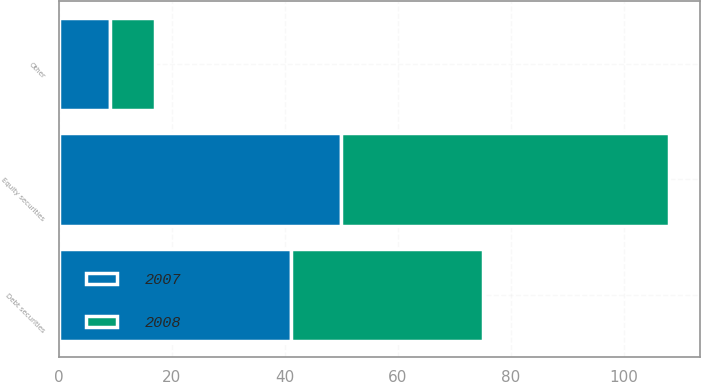Convert chart to OTSL. <chart><loc_0><loc_0><loc_500><loc_500><stacked_bar_chart><ecel><fcel>Equity securities<fcel>Debt securities<fcel>Other<nl><fcel>2007<fcel>50<fcel>41<fcel>9<nl><fcel>2008<fcel>58<fcel>34<fcel>8<nl></chart> 